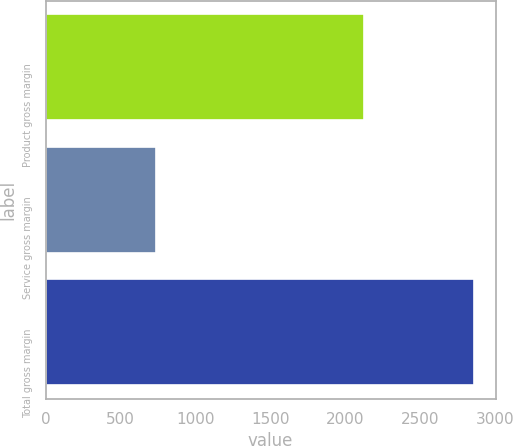Convert chart to OTSL. <chart><loc_0><loc_0><loc_500><loc_500><bar_chart><fcel>Product gross margin<fcel>Service gross margin<fcel>Total gross margin<nl><fcel>2121.9<fcel>736.3<fcel>2858.2<nl></chart> 